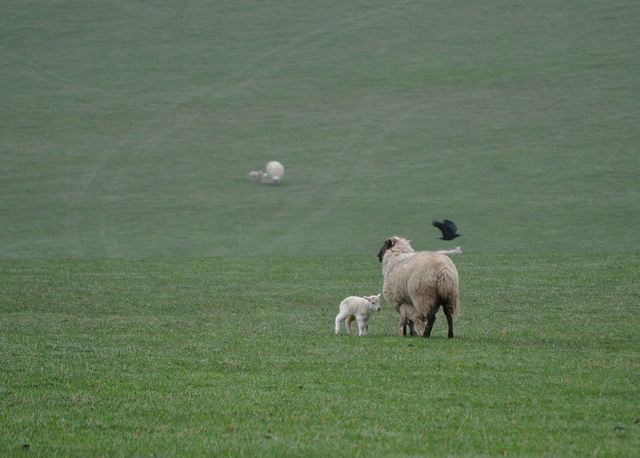Describe the objects in this image and their specific colors. I can see sheep in gray, darkgray, and black tones, sheep in gray, darkgray, and lightgray tones, sheep in gray and black tones, bird in gray, black, and purple tones, and sheep in gray, darkgray, and lightgray tones in this image. 